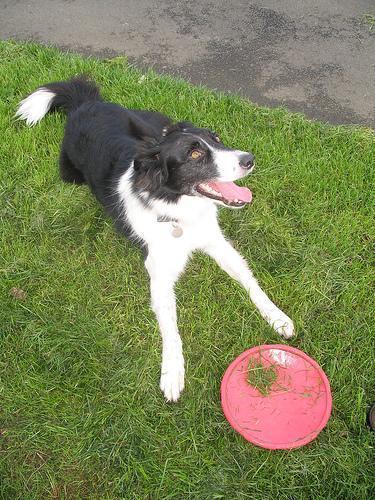How many dogs are in the photo?
Give a very brief answer. 1. 